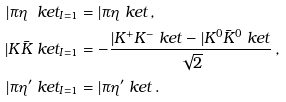<formula> <loc_0><loc_0><loc_500><loc_500>| \pi \eta \ k e t _ { I = 1 } & = | \pi \eta \ k e t \, , \\ | K \bar { K } \ k e t _ { I = 1 } & = - \frac { | K ^ { + } K ^ { - } \ k e t - | K ^ { 0 } \bar { K } ^ { 0 } \ k e t } { \sqrt { 2 } } \, , \\ | \pi \eta ^ { \prime } \ k e t _ { I = 1 } & = | \pi \eta ^ { \prime } \ k e t \, .</formula> 